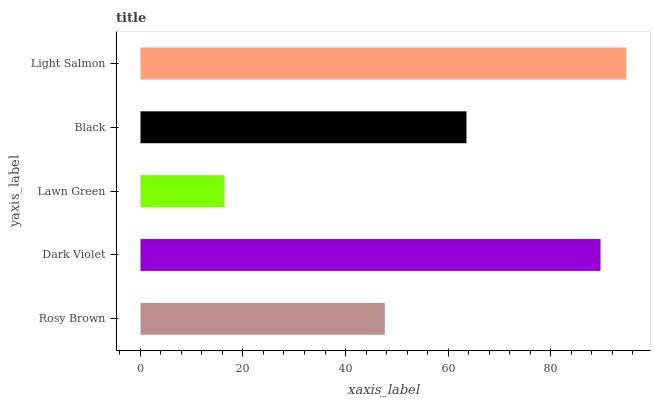Is Lawn Green the minimum?
Answer yes or no. Yes. Is Light Salmon the maximum?
Answer yes or no. Yes. Is Dark Violet the minimum?
Answer yes or no. No. Is Dark Violet the maximum?
Answer yes or no. No. Is Dark Violet greater than Rosy Brown?
Answer yes or no. Yes. Is Rosy Brown less than Dark Violet?
Answer yes or no. Yes. Is Rosy Brown greater than Dark Violet?
Answer yes or no. No. Is Dark Violet less than Rosy Brown?
Answer yes or no. No. Is Black the high median?
Answer yes or no. Yes. Is Black the low median?
Answer yes or no. Yes. Is Rosy Brown the high median?
Answer yes or no. No. Is Rosy Brown the low median?
Answer yes or no. No. 